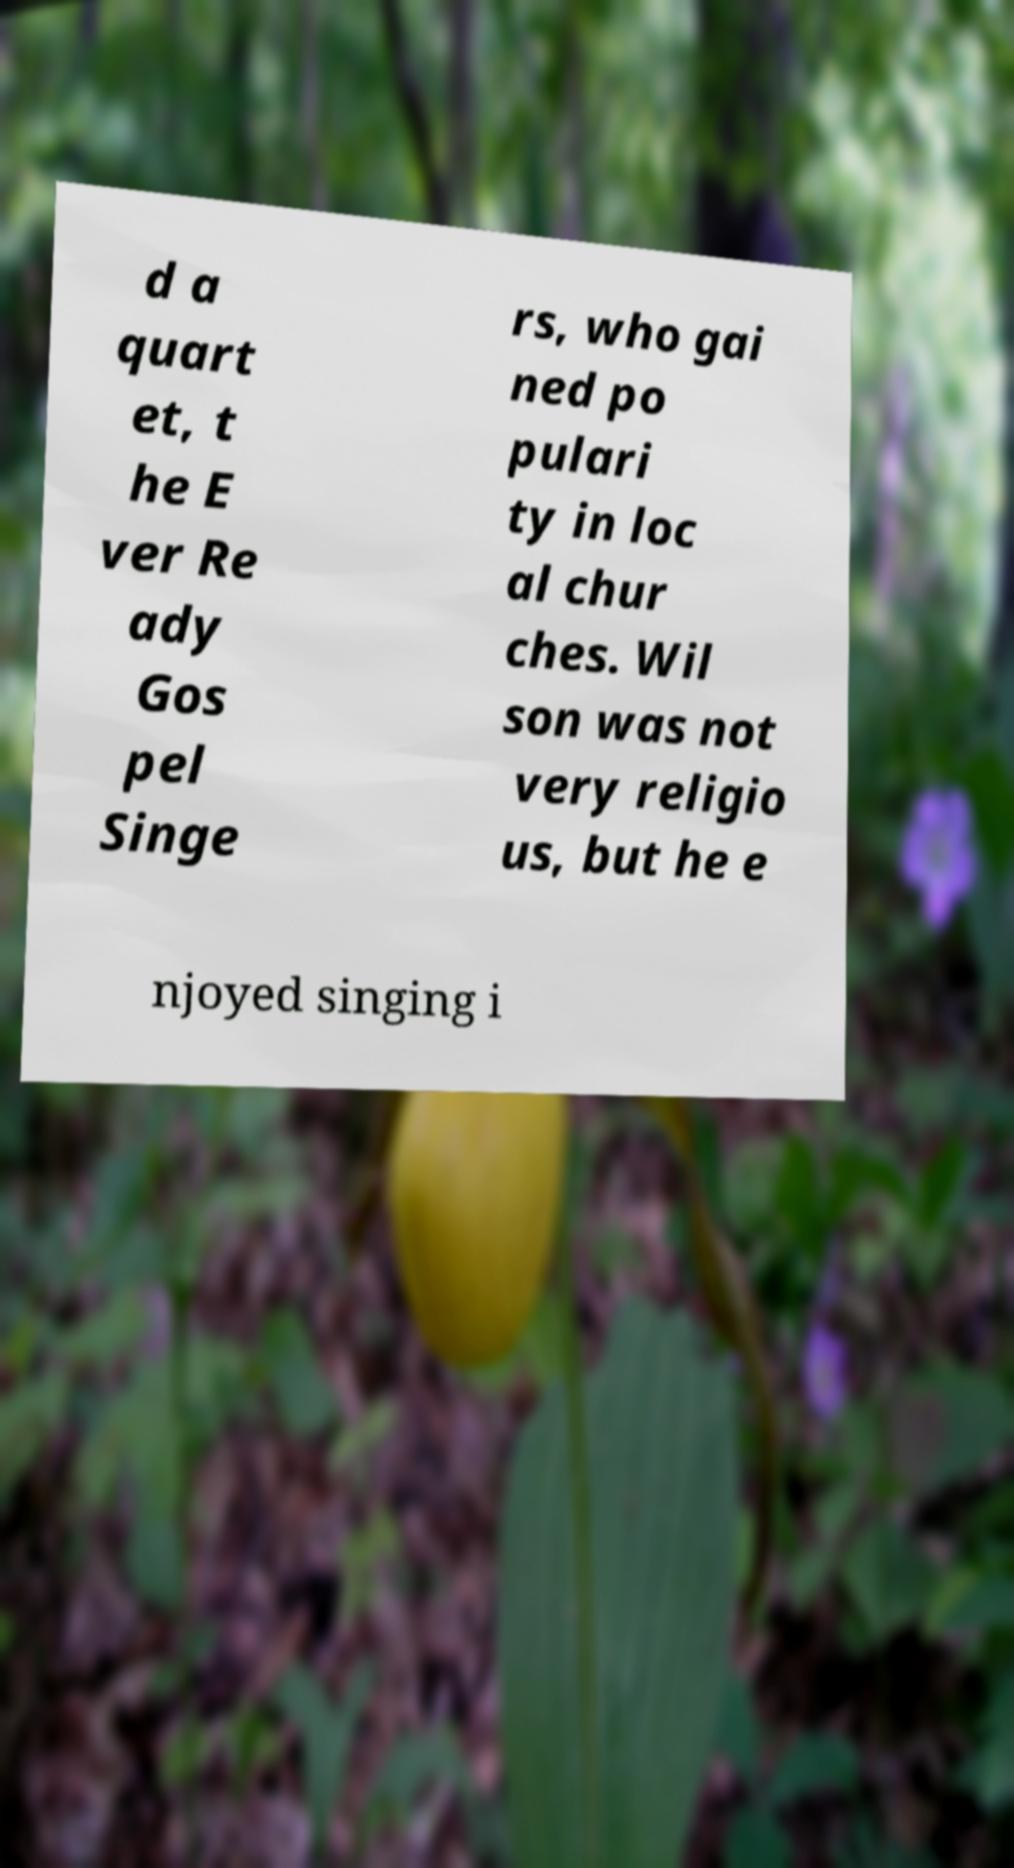Can you read and provide the text displayed in the image?This photo seems to have some interesting text. Can you extract and type it out for me? d a quart et, t he E ver Re ady Gos pel Singe rs, who gai ned po pulari ty in loc al chur ches. Wil son was not very religio us, but he e njoyed singing i 